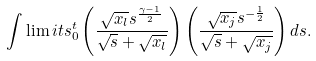Convert formula to latex. <formula><loc_0><loc_0><loc_500><loc_500>\int \lim i t s _ { 0 } ^ { t } \left ( \frac { \sqrt { x _ { l } } s ^ { \frac { \gamma - 1 } { 2 } } } { \sqrt { s } + \sqrt { x _ { l } } } \right ) \left ( \frac { \sqrt { x _ { j } } s ^ { - \frac { 1 } { 2 } } } { \sqrt { s } + \sqrt { x _ { j } } } \right ) d s .</formula> 